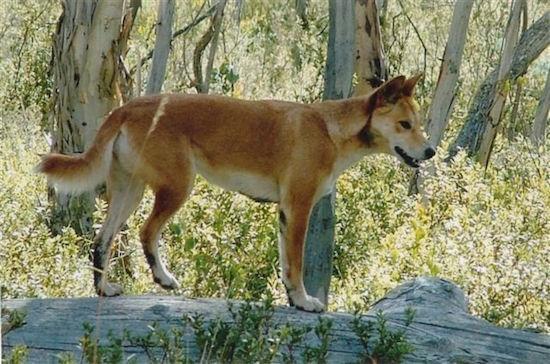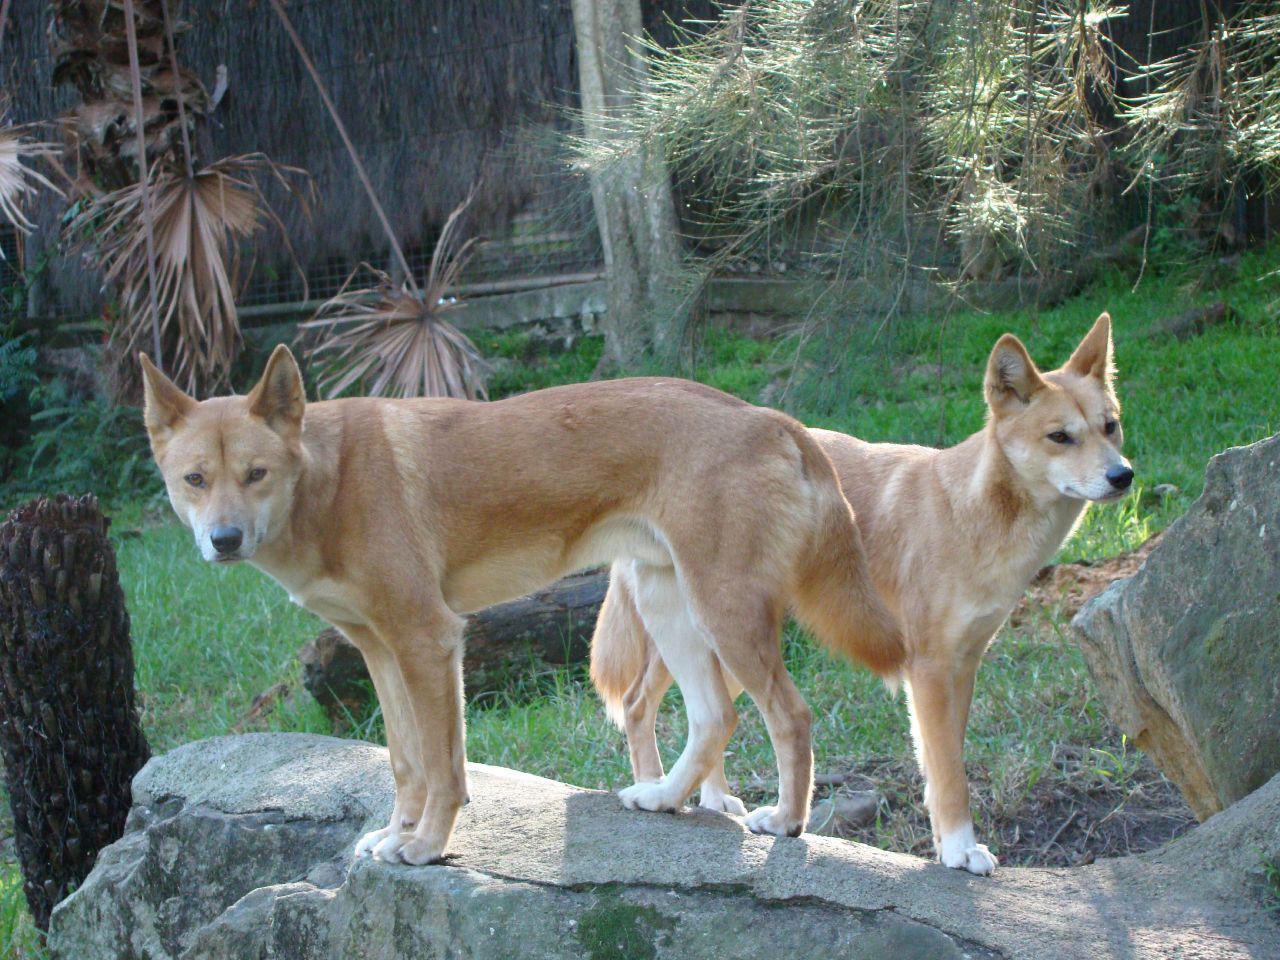The first image is the image on the left, the second image is the image on the right. Considering the images on both sides, is "The left image contains one standing dingo and a fallen log, and the right image contains exactly two standing dingos." valid? Answer yes or no. Yes. The first image is the image on the left, the second image is the image on the right. Analyze the images presented: Is the assertion "One of the images contains a single dog in a wooded area." valid? Answer yes or no. Yes. 